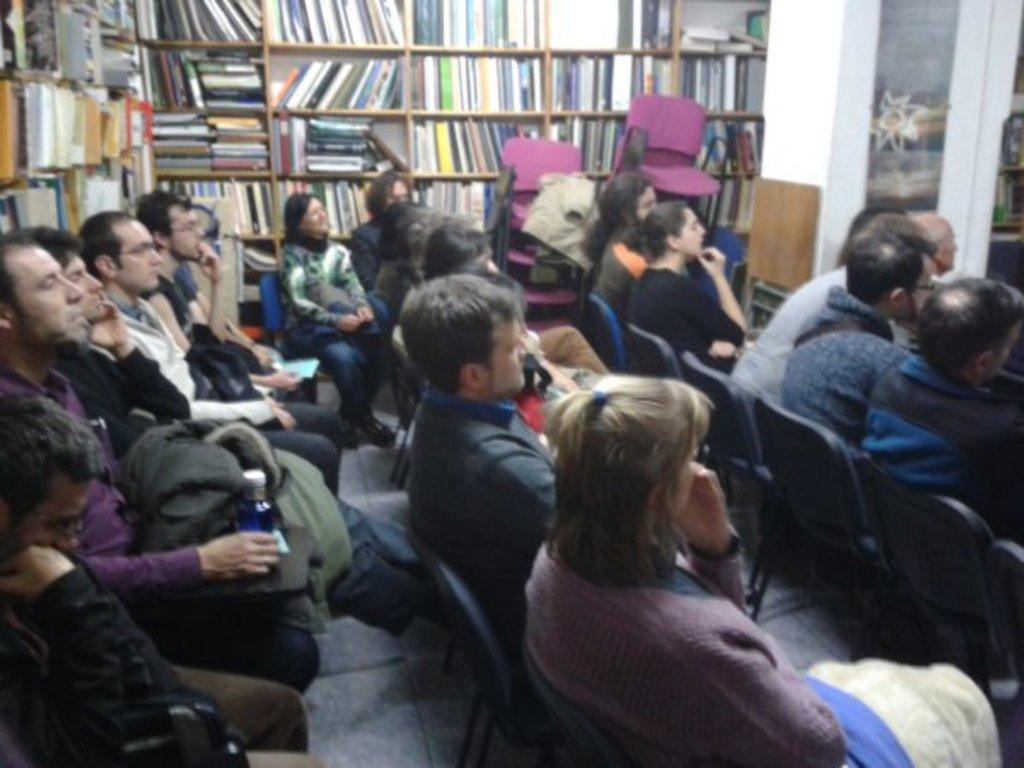What is happening in the image involving a group of people? In the image, there is a group of people sitting on chairs. What can be seen in the background of the image? In the background of the image, there are books in a book rack and chairs. Can you describe the books in the image? The books are in a book rack, which suggests they are organized and easily accessible. What type of flame can be seen on the cover of the books in the image? There is no flame present on the cover of the books in the image, as the books are in a book rack and do not have any visible covers. 